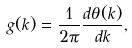<formula> <loc_0><loc_0><loc_500><loc_500>g ( k ) = \frac { 1 } { 2 \pi } \frac { d \theta ( k ) } { d k } ,</formula> 